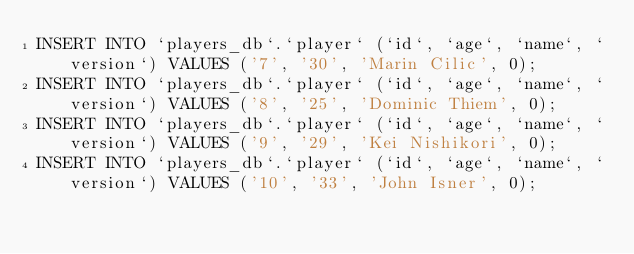Convert code to text. <code><loc_0><loc_0><loc_500><loc_500><_SQL_>INSERT INTO `players_db`.`player` (`id`, `age`, `name`, `version`) VALUES ('7', '30', 'Marin Cilic', 0);
INSERT INTO `players_db`.`player` (`id`, `age`, `name`, `version`) VALUES ('8', '25', 'Dominic Thiem', 0);
INSERT INTO `players_db`.`player` (`id`, `age`, `name`, `version`) VALUES ('9', '29', 'Kei Nishikori', 0);
INSERT INTO `players_db`.`player` (`id`, `age`, `name`, `version`) VALUES ('10', '33', 'John Isner', 0);
</code> 